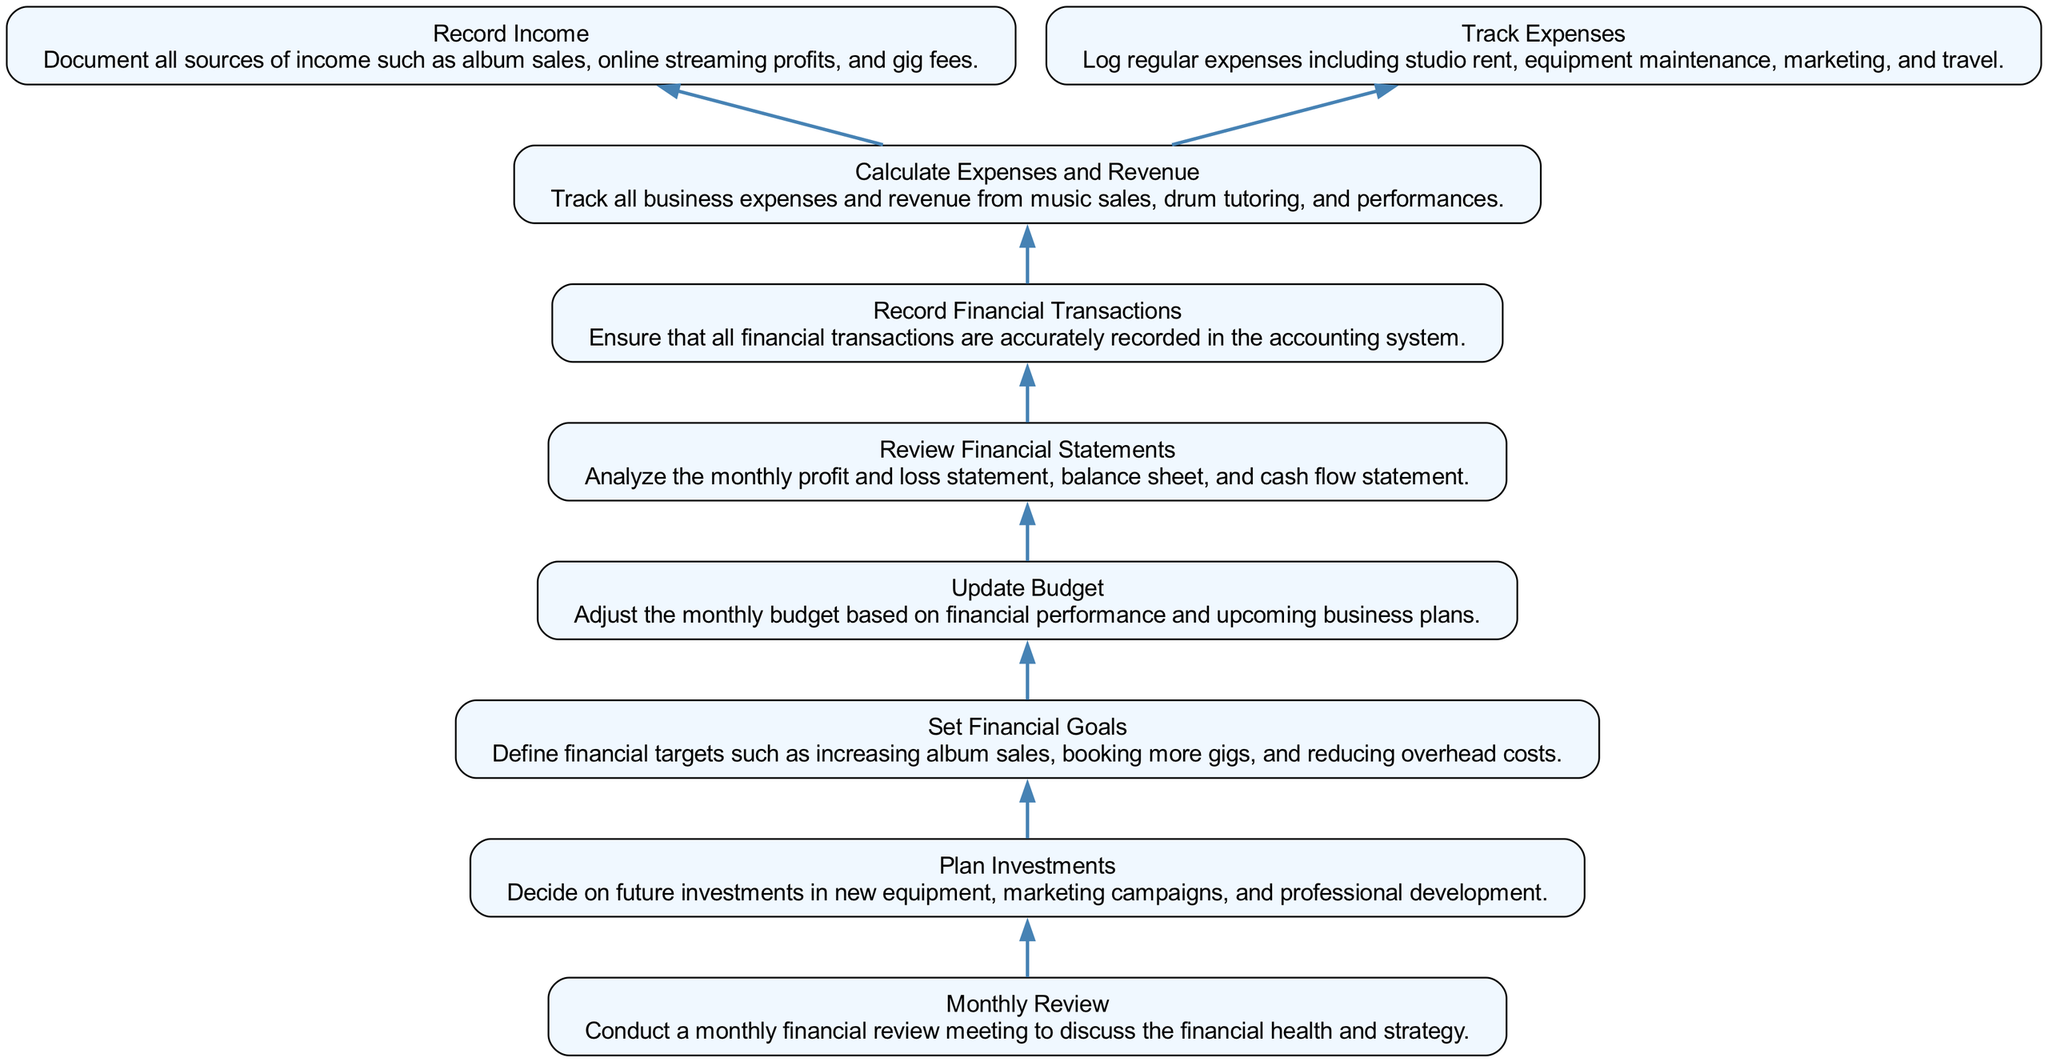What is the first step in the monthly financial management process? According to the diagram, the first step is to calculate expenses and revenue. This is the base of the flow as it's the first node listed.
Answer: Calculate Expenses and Revenue How many total nodes are present in the diagram? By counting the various elements represented, there are nine distinct nodes in the diagram.
Answer: Nine What comes after reviewing financial statements in the flow? After reviewing financial statements, the next step in the flow diagram is to update the budget. This shows a direct progression from one step to another.
Answer: Update Budget Which node is directly linked to setting financial goals? The node linked to setting financial goals is updating the budget. This indicates that you need to first update your budget before you can set financial goals.
Answer: Update Budget What is the relationship between recording financial transactions and calculating expenses and revenue? Recording financial transactions is a precursor to calculating expenses and revenue. The flow shows that financial transactions need to be recorded first in order to assess expenses and revenue effectively.
Answer: Preceding What aspect does planning investments correlate with in this diagram? Planning investments is correlated with setting financial goals. This connection indicates that before making investment decisions, you have to establish clear financial objectives.
Answer: Setting Financial Goals Which two processes are involved in calculating expenses and revenue? The two processes involved are recording income and tracking expenses. Both are essential components of calculating the overall expenses and revenue.
Answer: Recording Income and Tracking Expenses What is the final step in the monthly financial management flow? The last step is conducting a monthly review. It is positioned at the top of the diagram, indicating the culmination of the financial management process.
Answer: Monthly Review 